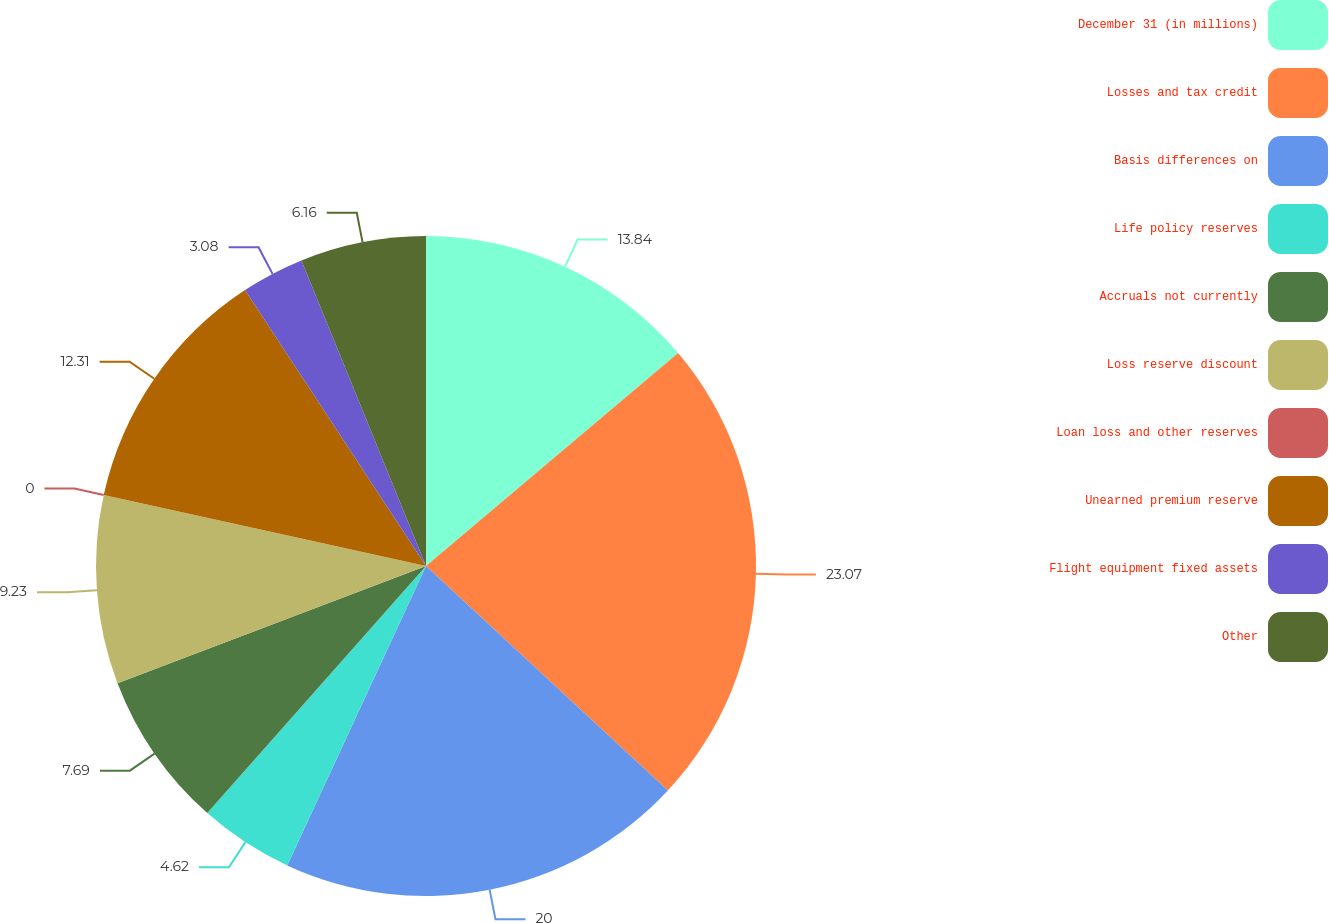Convert chart. <chart><loc_0><loc_0><loc_500><loc_500><pie_chart><fcel>December 31 (in millions)<fcel>Losses and tax credit<fcel>Basis differences on<fcel>Life policy reserves<fcel>Accruals not currently<fcel>Loss reserve discount<fcel>Loan loss and other reserves<fcel>Unearned premium reserve<fcel>Flight equipment fixed assets<fcel>Other<nl><fcel>13.84%<fcel>23.07%<fcel>20.0%<fcel>4.62%<fcel>7.69%<fcel>9.23%<fcel>0.0%<fcel>12.31%<fcel>3.08%<fcel>6.16%<nl></chart> 